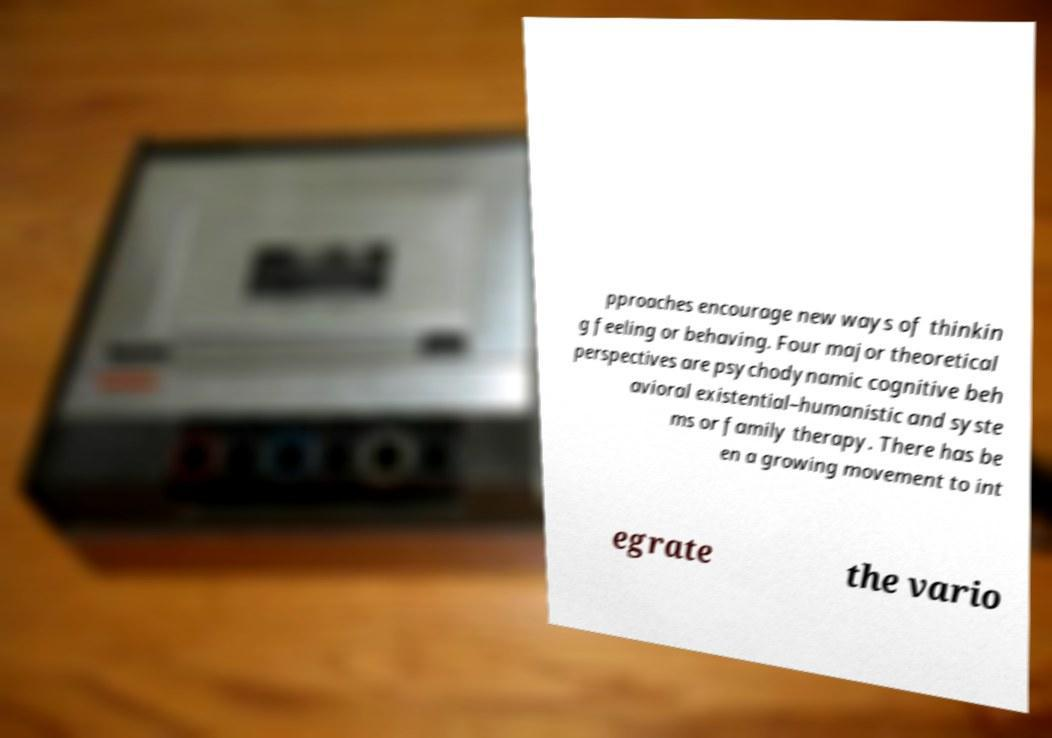Please identify and transcribe the text found in this image. pproaches encourage new ways of thinkin g feeling or behaving. Four major theoretical perspectives are psychodynamic cognitive beh avioral existential–humanistic and syste ms or family therapy. There has be en a growing movement to int egrate the vario 